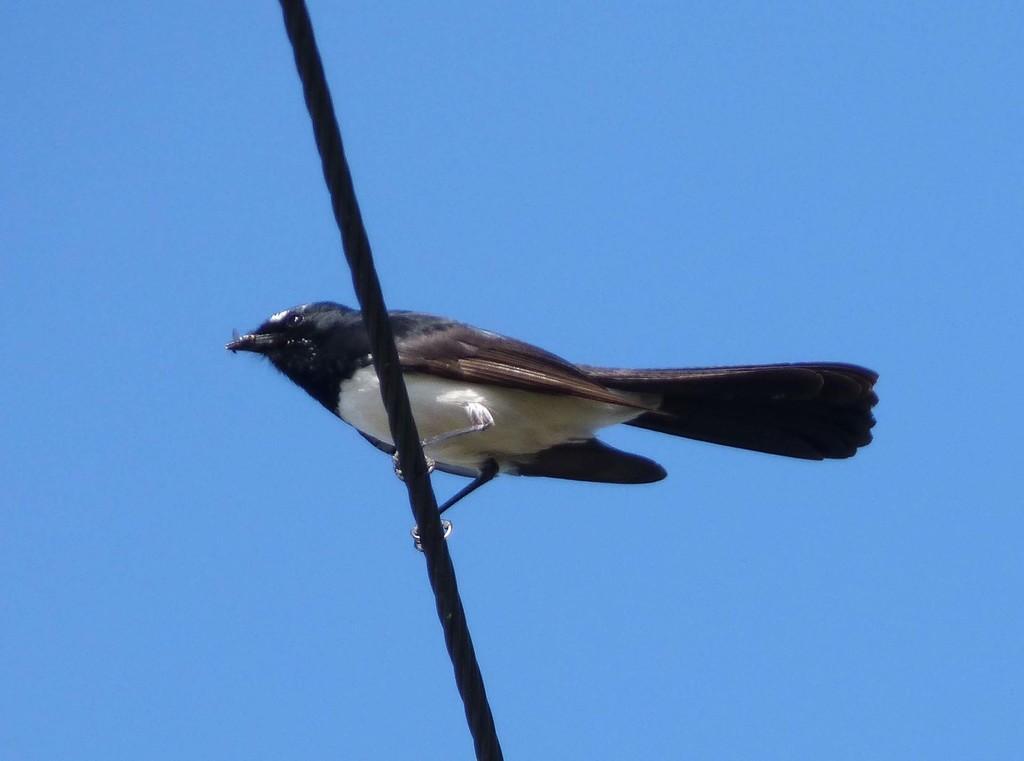In one or two sentences, can you explain what this image depicts? In this picture I can see a bird is standing on a rope in the middle. In the background there is the sky. 